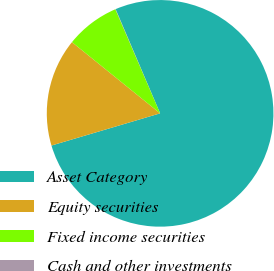Convert chart. <chart><loc_0><loc_0><loc_500><loc_500><pie_chart><fcel>Asset Category<fcel>Equity securities<fcel>Fixed income securities<fcel>Cash and other investments<nl><fcel>76.84%<fcel>15.4%<fcel>7.72%<fcel>0.04%<nl></chart> 